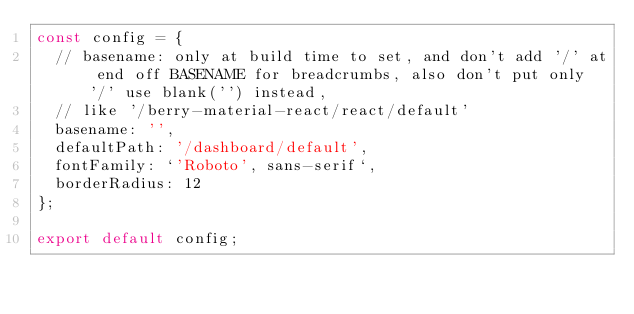Convert code to text. <code><loc_0><loc_0><loc_500><loc_500><_JavaScript_>const config = {
  // basename: only at build time to set, and don't add '/' at end off BASENAME for breadcrumbs, also don't put only '/' use blank('') instead,
  // like '/berry-material-react/react/default'
  basename: '',
  defaultPath: '/dashboard/default',
  fontFamily: `'Roboto', sans-serif`,
  borderRadius: 12
};

export default config;
</code> 